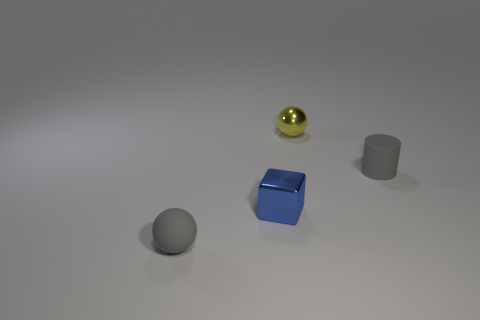The tiny matte object that is the same color as the small matte sphere is what shape?
Keep it short and to the point. Cylinder. There is a yellow thing; what shape is it?
Give a very brief answer. Sphere. Do the small rubber cylinder and the rubber sphere have the same color?
Provide a succinct answer. Yes. What number of objects are small spheres right of the gray matte sphere or big yellow metallic spheres?
Keep it short and to the point. 1. There is a ball that is made of the same material as the small gray cylinder; what is its size?
Keep it short and to the point. Small. Is the number of matte things on the left side of the yellow metallic thing greater than the number of big red metallic spheres?
Offer a very short reply. Yes. Is the shape of the yellow object the same as the small rubber thing to the left of the small cube?
Ensure brevity in your answer.  Yes. How many small things are matte spheres or cylinders?
Give a very brief answer. 2. What is the size of the object that is the same color as the cylinder?
Make the answer very short. Small. What is the color of the shiny thing that is behind the tiny gray matte object on the right side of the small blue object?
Your answer should be compact. Yellow. 